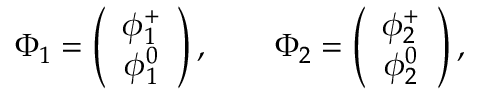Convert formula to latex. <formula><loc_0><loc_0><loc_500><loc_500>\Phi _ { 1 } = \left ( \begin{array} { c } { { \phi _ { 1 } ^ { + } } } \\ { { \phi _ { 1 } ^ { 0 } } } \end{array} \right ) , \quad \Phi _ { 2 } = \left ( \begin{array} { c } { { \phi _ { 2 } ^ { + } } } \\ { { \phi _ { 2 } ^ { 0 } } } \end{array} \right ) ,</formula> 